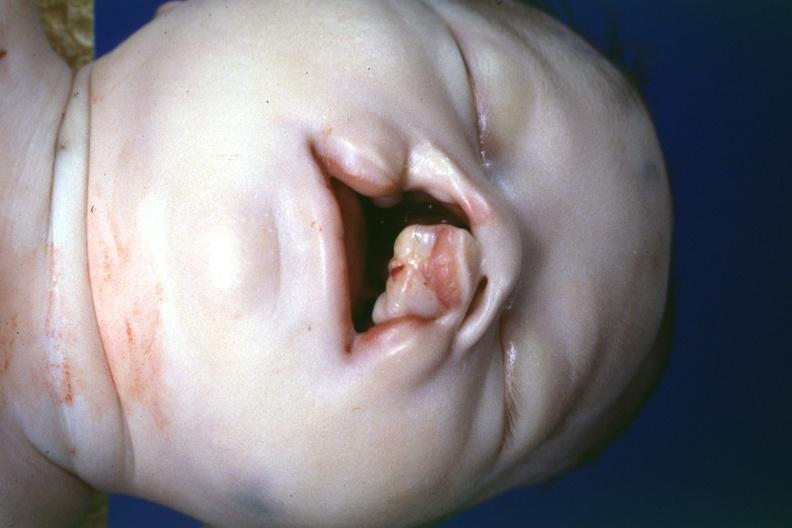s myoma lesion present?
Answer the question using a single word or phrase. No 